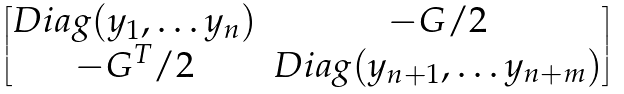Convert formula to latex. <formula><loc_0><loc_0><loc_500><loc_500>\begin{bmatrix} D i a g ( y _ { 1 } , \dots y _ { n } ) & - G / 2 \\ - G ^ { T } / 2 & D i a g ( y _ { n + 1 } , \dots y _ { n + m } ) \end{bmatrix}</formula> 